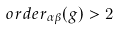<formula> <loc_0><loc_0><loc_500><loc_500>o r d e r _ { \alpha \beta } ( g ) > 2</formula> 